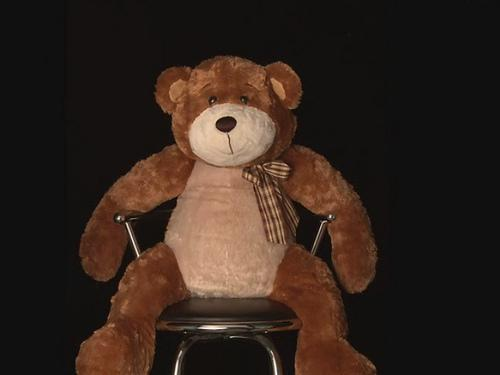Question: where was the photo taken?
Choices:
A. In a store.
B. Wal Mart.
C. Mall.
D. BiLO.
Answer with the letter. Answer: A Question: who is in the photo?
Choices:
A. My family.
B. Nobody.
C. The children.
D. The football players.
Answer with the letter. Answer: B Question: what is in the photo?
Choices:
A. A new car.
B. A sailboat.
C. A teddy bear.
D. An RV.
Answer with the letter. Answer: C Question: how is the photo?
Choices:
A. Dull.
B. Clear.
C. Hazy.
D. Dark.
Answer with the letter. Answer: B Question: what is the teddy dear sitting on?
Choices:
A. The sofa.
B. The couch.
C. The drawer.
D. The chair.
Answer with the letter. Answer: D Question: why is the picture clear?
Choices:
A. The area is dark.
B. The area is dim.
C. The area is faded.
D. The area is lit.
Answer with the letter. Answer: D 